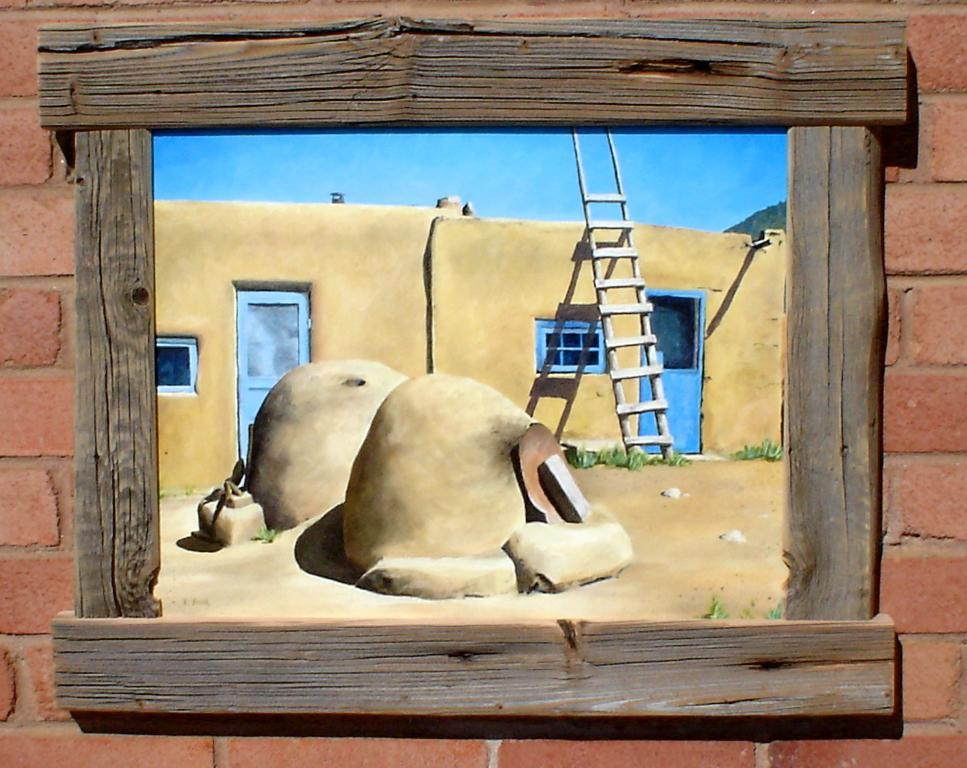What is attached to the wall in the image? There is a frame attached to the wall in the image. What is the color of the wall? The wall is maroon in color. What is depicted in the frame? The frame contains a picture with stones. What is shown in the picture? The picture shows a brown-colored house. What features of the house can be seen in the image? The house has doors. What is the color of the sky in the image? The sky is blue in color. Are there any giants visible in the image? No, there are no giants present in the image. What type of sock is hanging on the brown-colored house in the image? There is no sock present in the image; it features a frame with a picture of a house. 